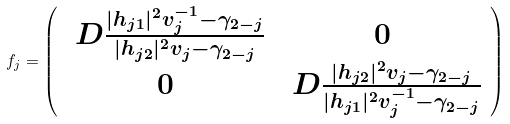Convert formula to latex. <formula><loc_0><loc_0><loc_500><loc_500>f _ { j } = \left ( \begin{array} { c c } \ D \frac { | h _ { j 1 } | ^ { 2 } v _ { j } ^ { - 1 } - \gamma _ { 2 - j } } { | h _ { j 2 } | ^ { 2 } v _ { j } - \gamma _ { 2 - j } } & 0 \\ 0 & \ D \frac { | h _ { j 2 } | ^ { 2 } v _ { j } - \gamma _ { 2 - j } } { | h _ { j 1 } | ^ { 2 } v _ { j } ^ { - 1 } - \gamma _ { 2 - j } } \end{array} \right )</formula> 